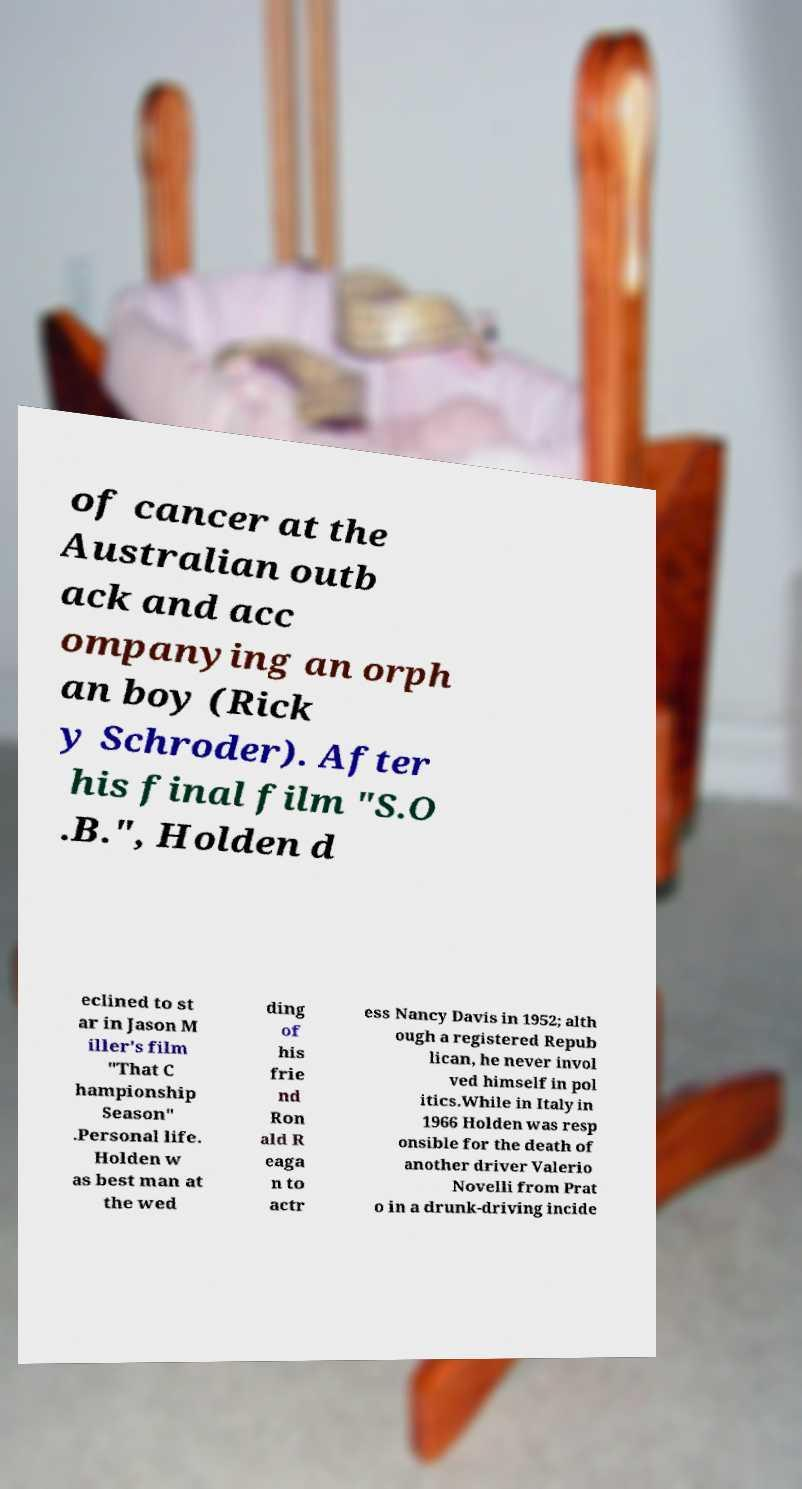What messages or text are displayed in this image? I need them in a readable, typed format. of cancer at the Australian outb ack and acc ompanying an orph an boy (Rick y Schroder). After his final film "S.O .B.", Holden d eclined to st ar in Jason M iller's film "That C hampionship Season" .Personal life. Holden w as best man at the wed ding of his frie nd Ron ald R eaga n to actr ess Nancy Davis in 1952; alth ough a registered Repub lican, he never invol ved himself in pol itics.While in Italy in 1966 Holden was resp onsible for the death of another driver Valerio Novelli from Prat o in a drunk-driving incide 